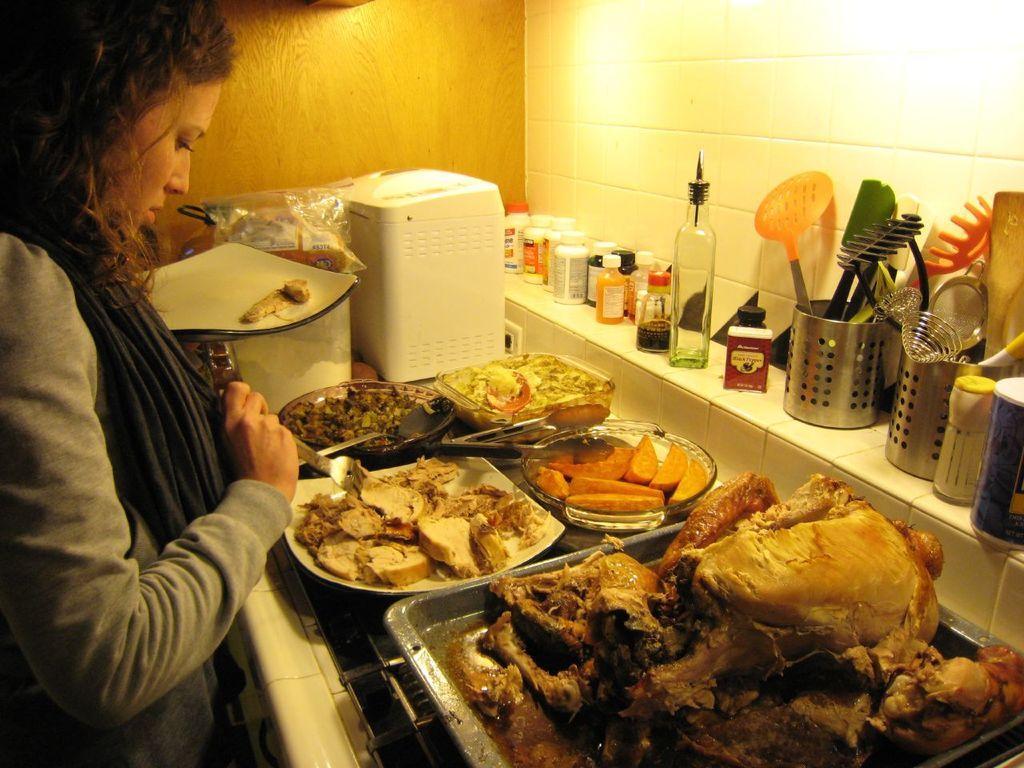Can you describe this image briefly? In this image I can see a woman standing, holding a fork in her hand, I can see a platform in front of her with different food items on the plates. I can see some containers, bottles, organizers with spoons on the platform. I can see an electronic device, a plate, and other objects in front of her. 